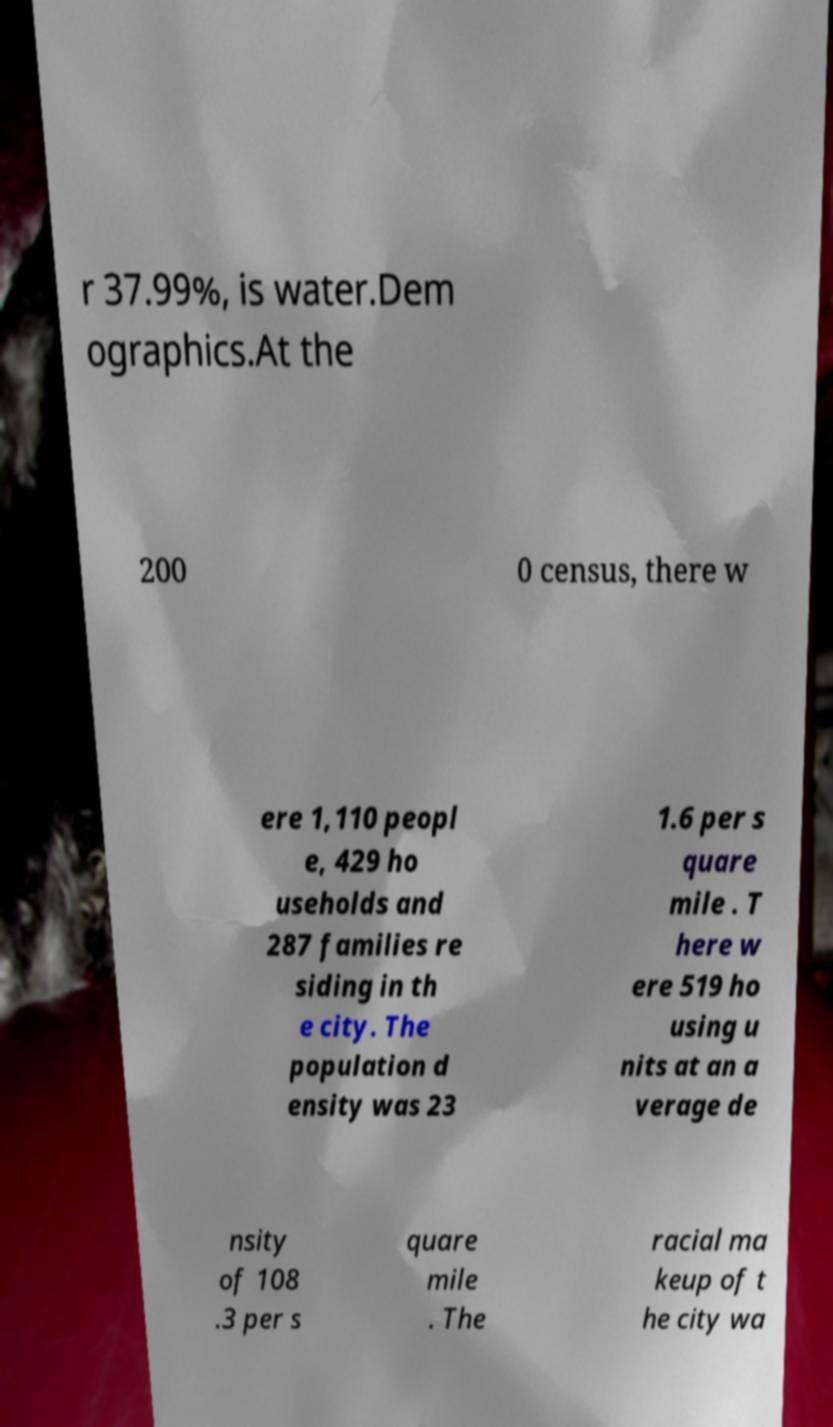Can you read and provide the text displayed in the image?This photo seems to have some interesting text. Can you extract and type it out for me? r 37.99%, is water.Dem ographics.At the 200 0 census, there w ere 1,110 peopl e, 429 ho useholds and 287 families re siding in th e city. The population d ensity was 23 1.6 per s quare mile . T here w ere 519 ho using u nits at an a verage de nsity of 108 .3 per s quare mile . The racial ma keup of t he city wa 